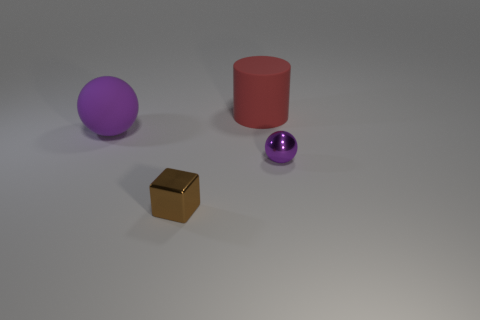Add 4 purple objects. How many objects exist? 8 Subtract all gray cylinders. Subtract all purple balls. How many cylinders are left? 1 Subtract all tiny metal cylinders. Subtract all shiny balls. How many objects are left? 3 Add 3 purple metallic spheres. How many purple metallic spheres are left? 4 Add 2 small brown things. How many small brown things exist? 3 Subtract 0 cyan blocks. How many objects are left? 4 Subtract all cubes. How many objects are left? 3 Subtract 1 cubes. How many cubes are left? 0 